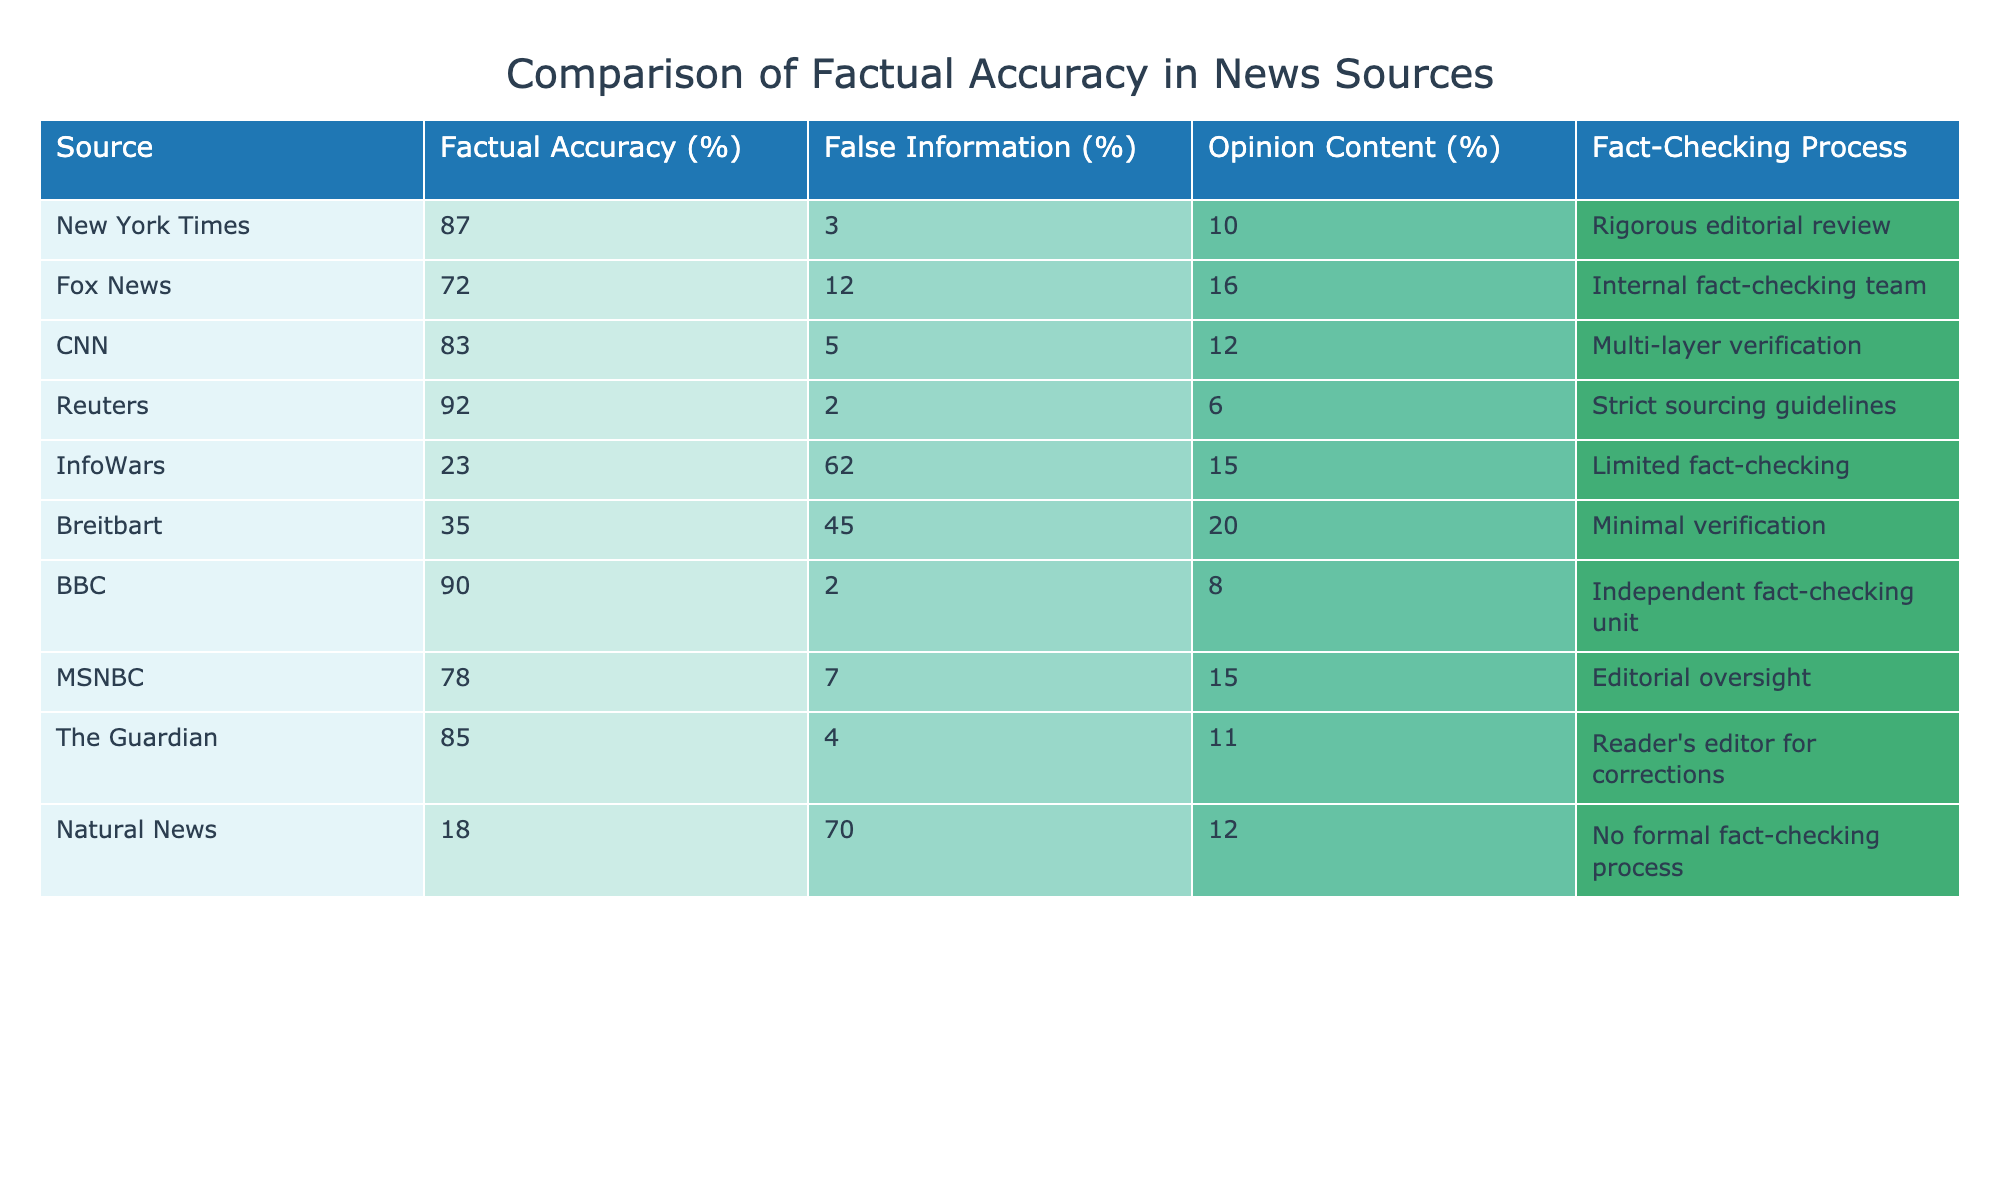What is the factual accuracy percentage of Reuters? The table shows that Reuters has a factual accuracy percentage of 92%.
Answer: 92% Which source has the highest percentage of false information? By looking at the percentages of false information in the table, InfoWars has the highest at 62%.
Answer: 62% What is the average factual accuracy of the news sources listed? To calculate the average, we sum the factual accuracy percentages: 87 + 72 + 83 + 92 + 23 + 35 + 90 + 78 + 85 + 18 = 783. There are 10 sources, so the average is 783/10 = 78.3%.
Answer: 78.3% Is the BBC more reliable in terms of factual accuracy compared to Fox News? In the table, BBC has a factual accuracy of 90%, while Fox News has a factual accuracy of 72%, indicating that BBC is indeed more reliable.
Answer: Yes Which outlet has the least rigorous fact-checking process, and what is its accuracy? Evaluating the fact-checking processes, Natural News states it has no formal fact-checking process and has a factual accuracy of 18%, which indicates it is the least rigorous.
Answer: Natural News, 18% 